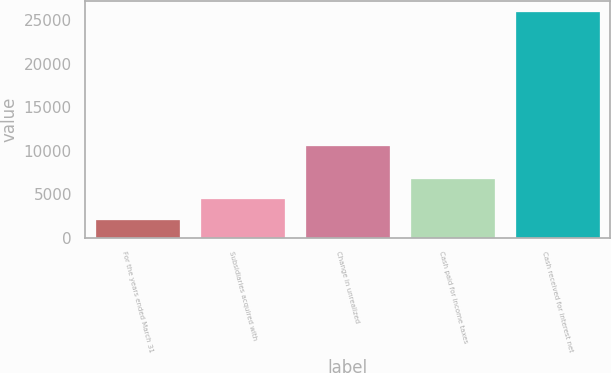Convert chart. <chart><loc_0><loc_0><loc_500><loc_500><bar_chart><fcel>For the years ended March 31<fcel>Subsidiaries acquired with<fcel>Change in unrealized<fcel>Cash paid for income taxes<fcel>Cash received for interest net<nl><fcel>2006<fcel>4396.6<fcel>10576<fcel>6787.2<fcel>25912<nl></chart> 